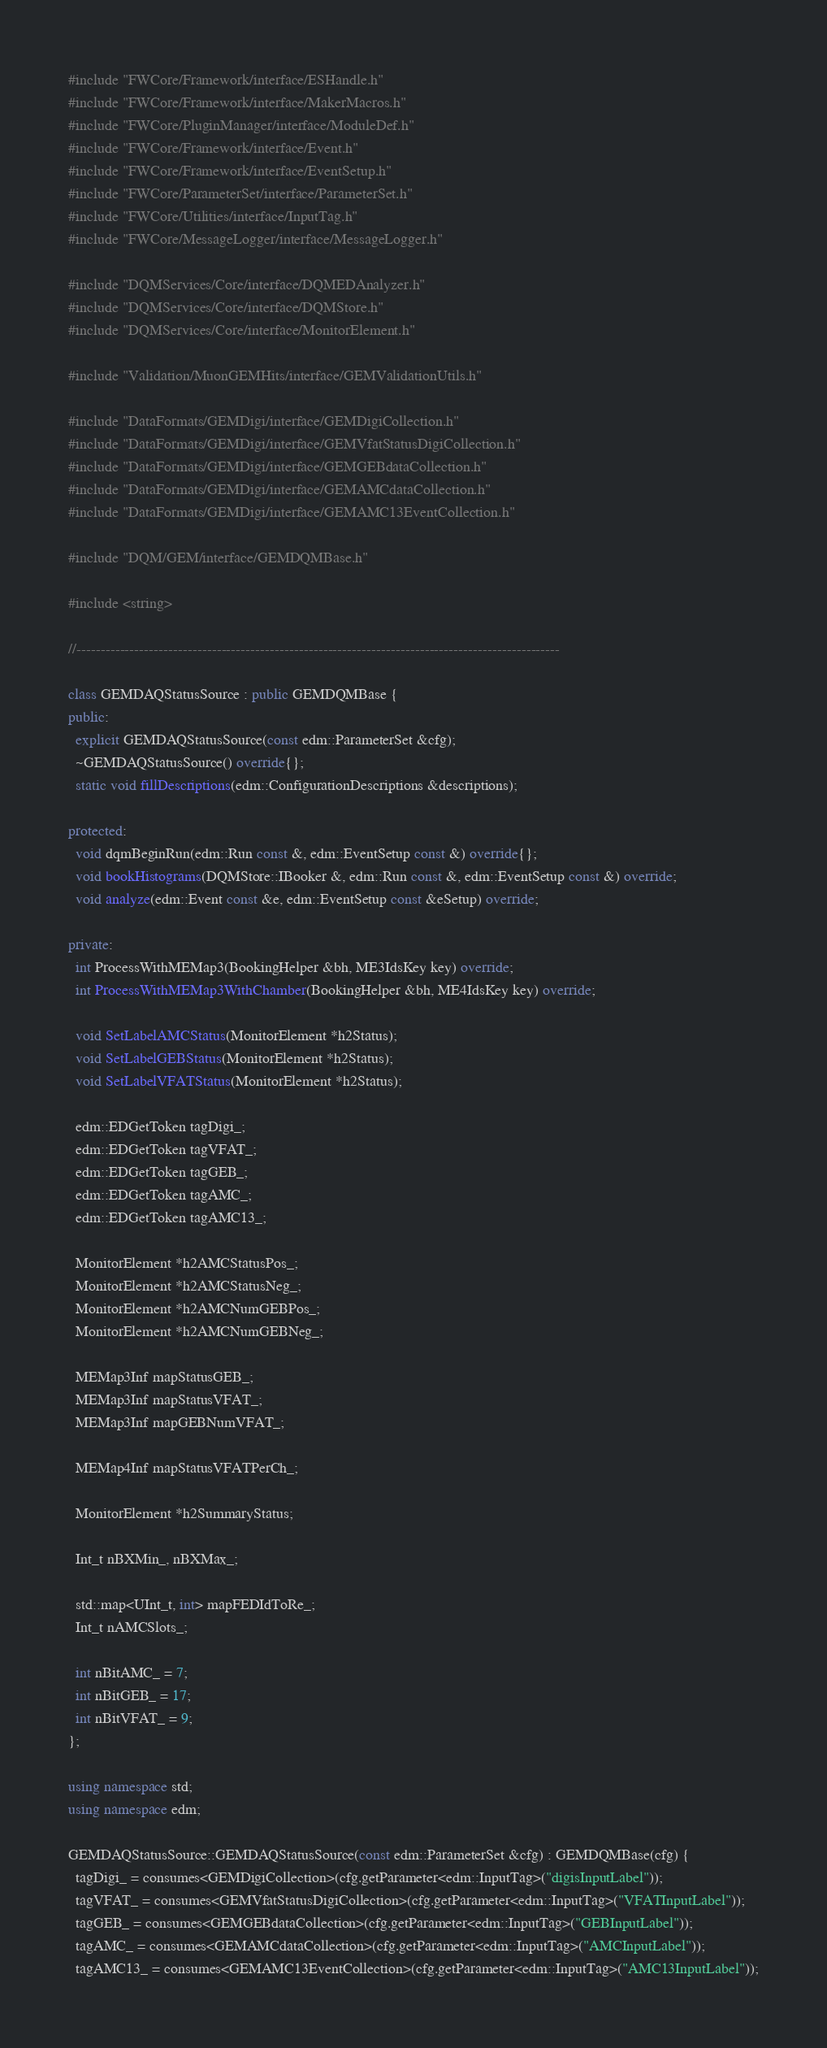Convert code to text. <code><loc_0><loc_0><loc_500><loc_500><_C++_>#include "FWCore/Framework/interface/ESHandle.h"
#include "FWCore/Framework/interface/MakerMacros.h"
#include "FWCore/PluginManager/interface/ModuleDef.h"
#include "FWCore/Framework/interface/Event.h"
#include "FWCore/Framework/interface/EventSetup.h"
#include "FWCore/ParameterSet/interface/ParameterSet.h"
#include "FWCore/Utilities/interface/InputTag.h"
#include "FWCore/MessageLogger/interface/MessageLogger.h"

#include "DQMServices/Core/interface/DQMEDAnalyzer.h"
#include "DQMServices/Core/interface/DQMStore.h"
#include "DQMServices/Core/interface/MonitorElement.h"

#include "Validation/MuonGEMHits/interface/GEMValidationUtils.h"

#include "DataFormats/GEMDigi/interface/GEMDigiCollection.h"
#include "DataFormats/GEMDigi/interface/GEMVfatStatusDigiCollection.h"
#include "DataFormats/GEMDigi/interface/GEMGEBdataCollection.h"
#include "DataFormats/GEMDigi/interface/GEMAMCdataCollection.h"
#include "DataFormats/GEMDigi/interface/GEMAMC13EventCollection.h"

#include "DQM/GEM/interface/GEMDQMBase.h"

#include <string>

//----------------------------------------------------------------------------------------------------

class GEMDAQStatusSource : public GEMDQMBase {
public:
  explicit GEMDAQStatusSource(const edm::ParameterSet &cfg);
  ~GEMDAQStatusSource() override{};
  static void fillDescriptions(edm::ConfigurationDescriptions &descriptions);

protected:
  void dqmBeginRun(edm::Run const &, edm::EventSetup const &) override{};
  void bookHistograms(DQMStore::IBooker &, edm::Run const &, edm::EventSetup const &) override;
  void analyze(edm::Event const &e, edm::EventSetup const &eSetup) override;

private:
  int ProcessWithMEMap3(BookingHelper &bh, ME3IdsKey key) override;
  int ProcessWithMEMap3WithChamber(BookingHelper &bh, ME4IdsKey key) override;

  void SetLabelAMCStatus(MonitorElement *h2Status);
  void SetLabelGEBStatus(MonitorElement *h2Status);
  void SetLabelVFATStatus(MonitorElement *h2Status);

  edm::EDGetToken tagDigi_;
  edm::EDGetToken tagVFAT_;
  edm::EDGetToken tagGEB_;
  edm::EDGetToken tagAMC_;
  edm::EDGetToken tagAMC13_;

  MonitorElement *h2AMCStatusPos_;
  MonitorElement *h2AMCStatusNeg_;
  MonitorElement *h2AMCNumGEBPos_;
  MonitorElement *h2AMCNumGEBNeg_;

  MEMap3Inf mapStatusGEB_;
  MEMap3Inf mapStatusVFAT_;
  MEMap3Inf mapGEBNumVFAT_;

  MEMap4Inf mapStatusVFATPerCh_;

  MonitorElement *h2SummaryStatus;

  Int_t nBXMin_, nBXMax_;

  std::map<UInt_t, int> mapFEDIdToRe_;
  Int_t nAMCSlots_;

  int nBitAMC_ = 7;
  int nBitGEB_ = 17;
  int nBitVFAT_ = 9;
};

using namespace std;
using namespace edm;

GEMDAQStatusSource::GEMDAQStatusSource(const edm::ParameterSet &cfg) : GEMDQMBase(cfg) {
  tagDigi_ = consumes<GEMDigiCollection>(cfg.getParameter<edm::InputTag>("digisInputLabel"));
  tagVFAT_ = consumes<GEMVfatStatusDigiCollection>(cfg.getParameter<edm::InputTag>("VFATInputLabel"));
  tagGEB_ = consumes<GEMGEBdataCollection>(cfg.getParameter<edm::InputTag>("GEBInputLabel"));
  tagAMC_ = consumes<GEMAMCdataCollection>(cfg.getParameter<edm::InputTag>("AMCInputLabel"));
  tagAMC13_ = consumes<GEMAMC13EventCollection>(cfg.getParameter<edm::InputTag>("AMC13InputLabel"));
</code> 